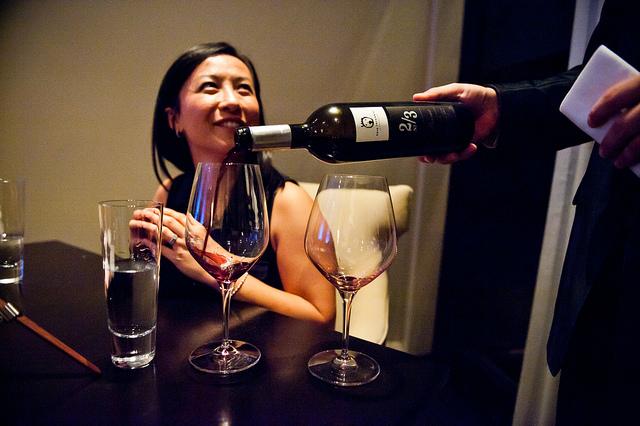Is he serving her wine?
Be succinct. Yes. Is the wine glass empty?
Answer briefly. Yes. Is she smiling at a waiter?
Answer briefly. Yes. How many glasses of water are in the picture?
Give a very brief answer. 2. What is the gender of the person pouring wine?
Give a very brief answer. Male. Where is the wine bottle?
Keep it brief. Hand. 